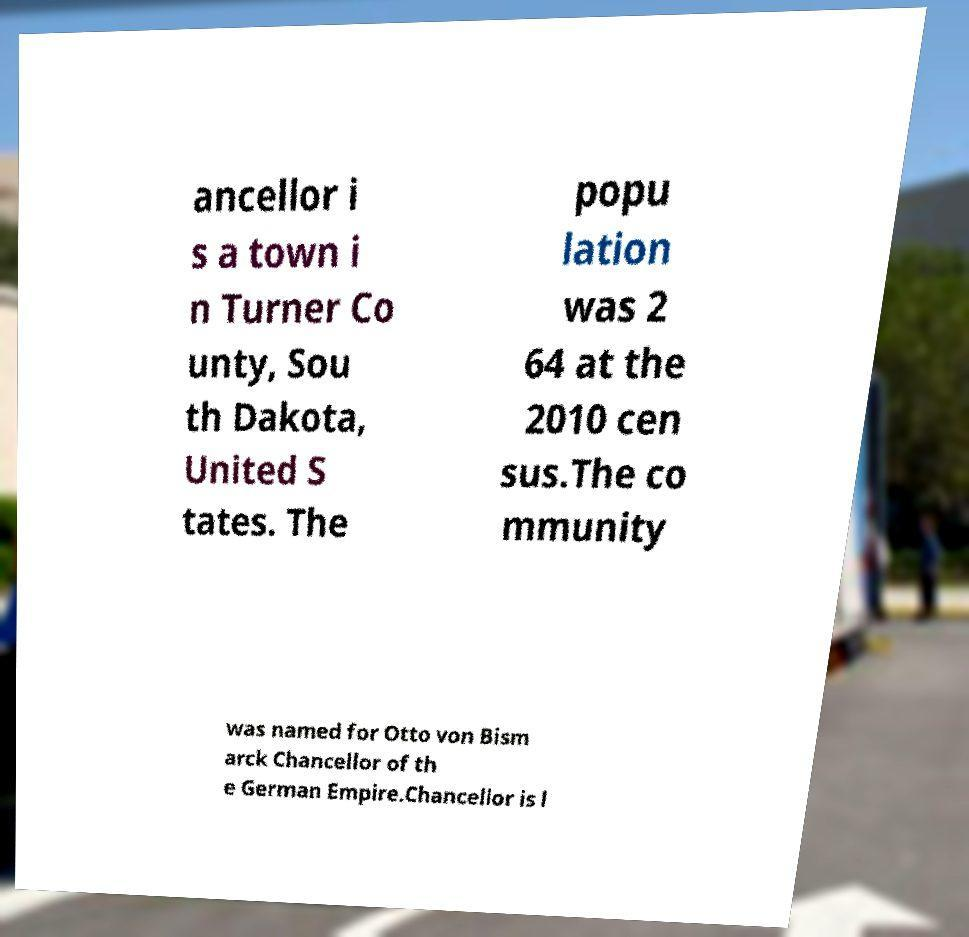Can you read and provide the text displayed in the image?This photo seems to have some interesting text. Can you extract and type it out for me? ancellor i s a town i n Turner Co unty, Sou th Dakota, United S tates. The popu lation was 2 64 at the 2010 cen sus.The co mmunity was named for Otto von Bism arck Chancellor of th e German Empire.Chancellor is l 